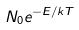<formula> <loc_0><loc_0><loc_500><loc_500>N _ { 0 } e ^ { - E / k T }</formula> 